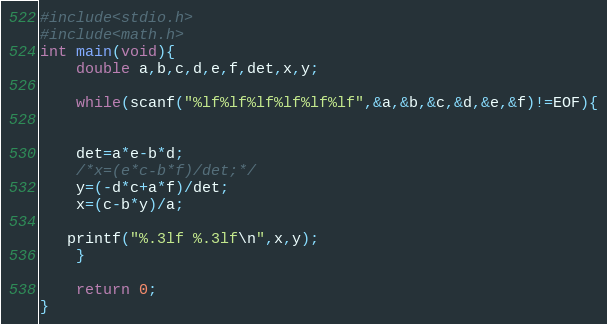Convert code to text. <code><loc_0><loc_0><loc_500><loc_500><_C_>#include<stdio.h>
#include<math.h>
int main(void){
    double a,b,c,d,e,f,det,x,y;
 
    while(scanf("%lf%lf%lf%lf%lf%lf",&a,&b,&c,&d,&e,&f)!=EOF){
 
 
    det=a*e-b*d;
    /*x=(e*c-b*f)/det;*/
    y=(-d*c+a*f)/det;
    x=(c-b*y)/a;
 
   printf("%.3lf %.3lf\n",x,y);
    }
 
    return 0;
}</code> 